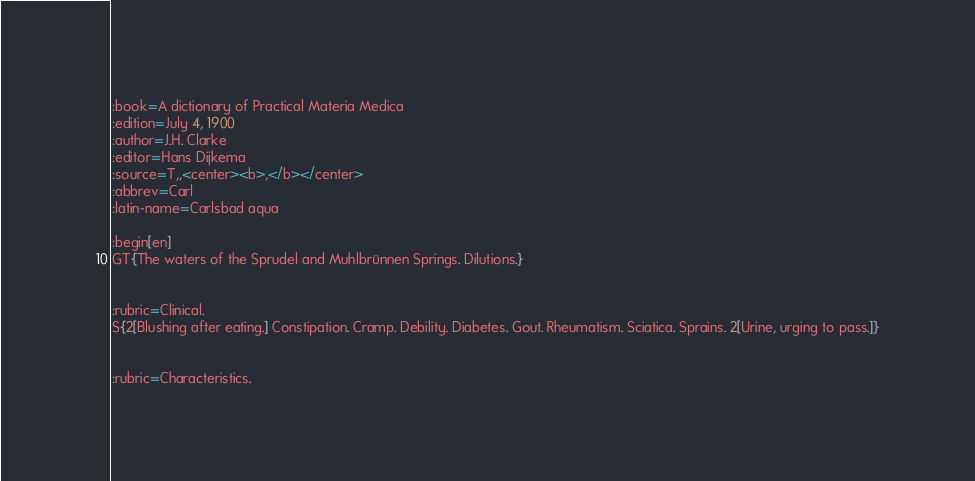<code> <loc_0><loc_0><loc_500><loc_500><_ObjectiveC_>:book=A dictionary of Practical Materia Medica
:edition=July 4, 1900
:author=J.H. Clarke
:editor=Hans Dijkema
:source=T,,<center><b>,</b></center>
:abbrev=Carl
:latin-name=Carlsbad aqua

:begin[en]
GT{The waters of the Sprudel and Muhlbrünnen Springs. Dilutions.}


:rubric=Clinical.
S{2[Blushing after eating.] Constipation. Cramp. Debility. Diabetes. Gout. Rheumatism. Sciatica. Sprains. 2[Urine, urging to pass.]}


:rubric=Characteristics.</code> 